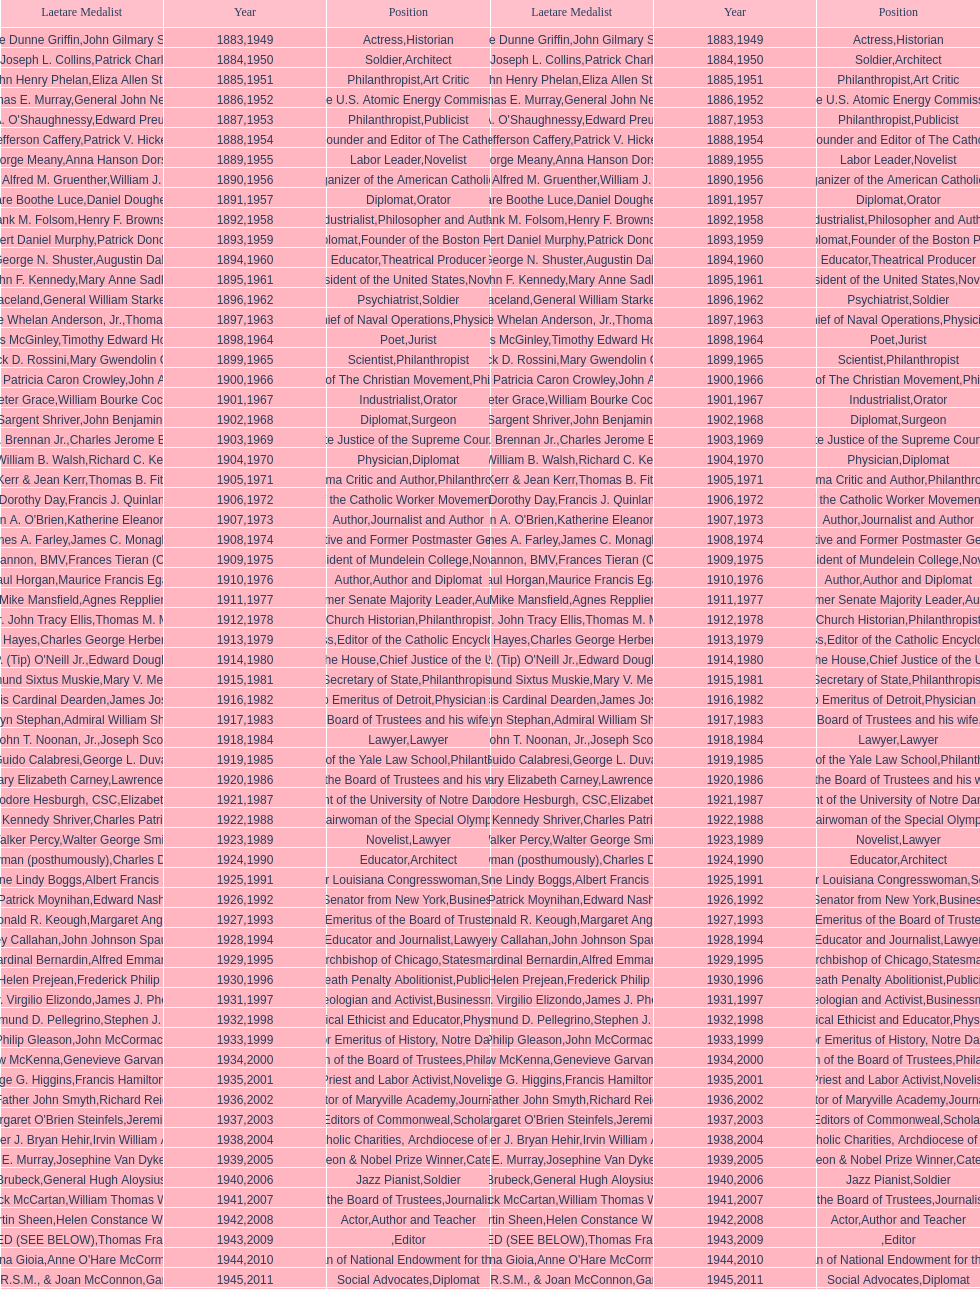Who has won this medal and the nobel prize as well? Dr. Joseph E. Murray. 